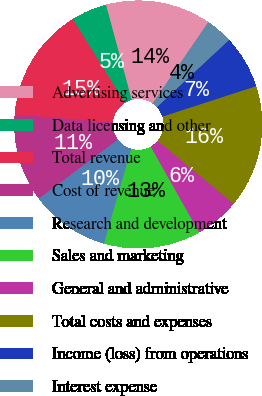Convert chart. <chart><loc_0><loc_0><loc_500><loc_500><pie_chart><fcel>Advertising services<fcel>Data licensing and other<fcel>Total revenue<fcel>Cost of revenue<fcel>Research and development<fcel>Sales and marketing<fcel>General and administrative<fcel>Total costs and expenses<fcel>Income (loss) from operations<fcel>Interest expense<nl><fcel>13.76%<fcel>4.65%<fcel>14.89%<fcel>11.48%<fcel>10.34%<fcel>12.62%<fcel>5.79%<fcel>16.03%<fcel>6.93%<fcel>3.51%<nl></chart> 